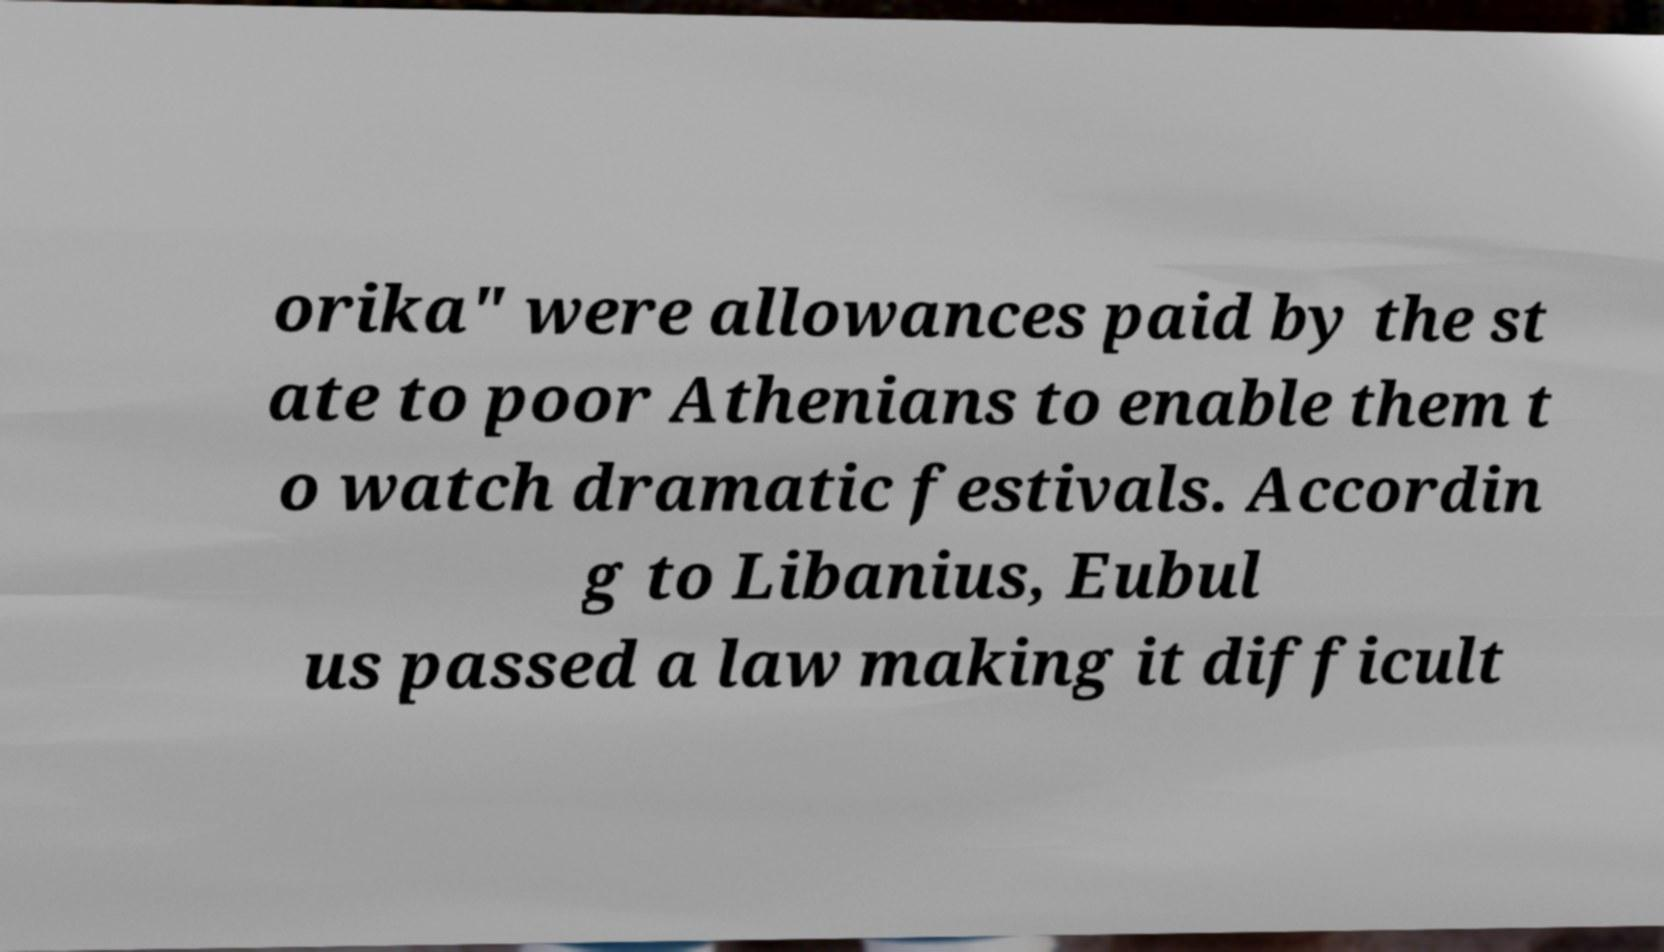Could you extract and type out the text from this image? orika" were allowances paid by the st ate to poor Athenians to enable them t o watch dramatic festivals. Accordin g to Libanius, Eubul us passed a law making it difficult 